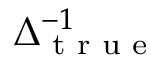<formula> <loc_0><loc_0><loc_500><loc_500>\Delta _ { t r u e } ^ { - 1 }</formula> 